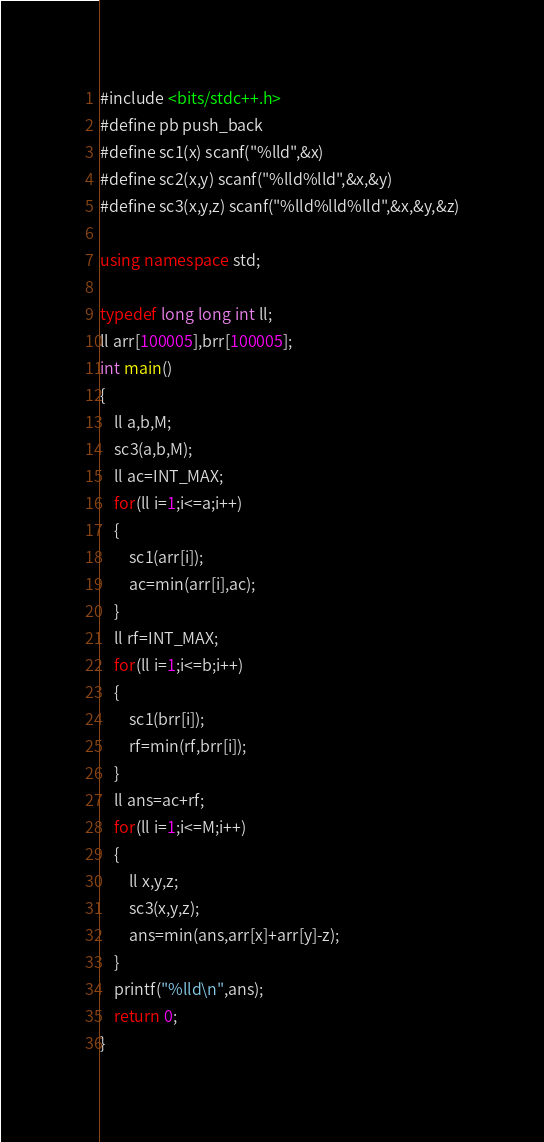Convert code to text. <code><loc_0><loc_0><loc_500><loc_500><_C++_>#include <bits/stdc++.h>
#define pb push_back
#define sc1(x) scanf("%lld",&x)
#define sc2(x,y) scanf("%lld%lld",&x,&y)
#define sc3(x,y,z) scanf("%lld%lld%lld",&x,&y,&z)

using namespace std;

typedef long long int ll;
ll arr[100005],brr[100005];
int main()
{
    ll a,b,M;
    sc3(a,b,M);
    ll ac=INT_MAX;
    for(ll i=1;i<=a;i++)
    {
        sc1(arr[i]);
        ac=min(arr[i],ac);
    }
    ll rf=INT_MAX;
    for(ll i=1;i<=b;i++)
    {
        sc1(brr[i]);
        rf=min(rf,brr[i]);
    }
    ll ans=ac+rf;
    for(ll i=1;i<=M;i++)
    {
        ll x,y,z;
        sc3(x,y,z);
        ans=min(ans,arr[x]+arr[y]-z);
    }
    printf("%lld\n",ans);
    return 0;
}
</code> 